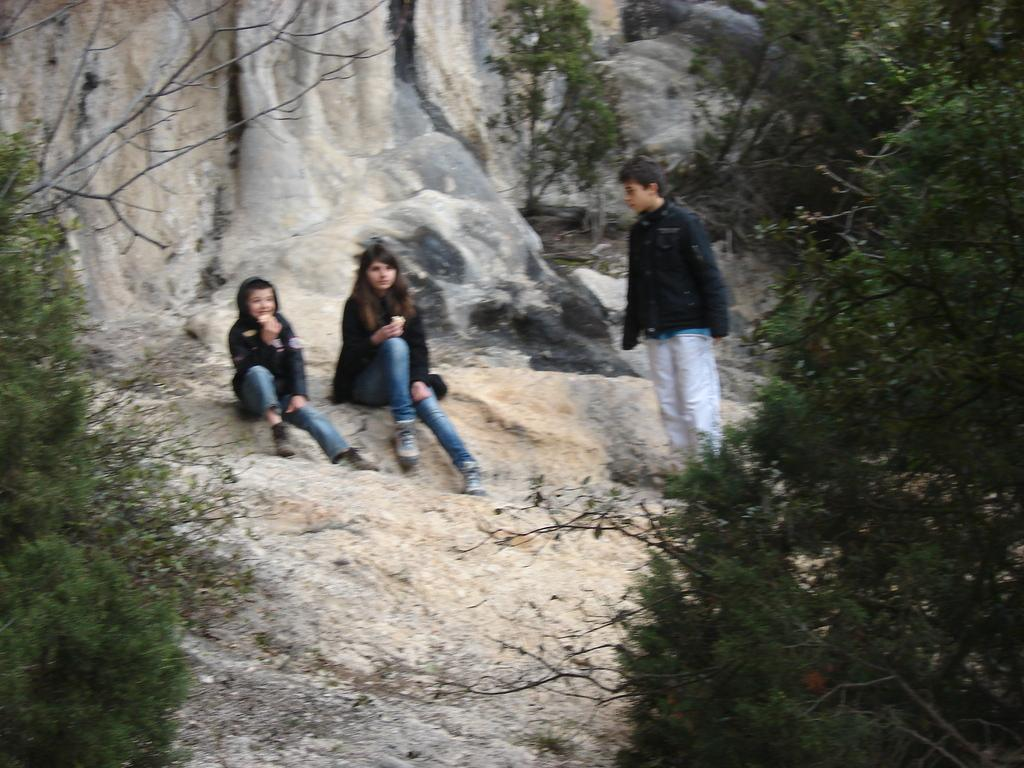What are the people in the image doing? The people in the image are sitting. On what are the people sitting? The people are sitting on rocks. What can be seen in the background of the image? There is a rock mountain in the background of the image. What type of vegetation is present in the image? There are trees around the people and the rock mountain. What type of current is flowing through the pot in the image? There is no pot or current present in the image. What material is the steel structure made of in the image? There is no steel structure present in the image. 